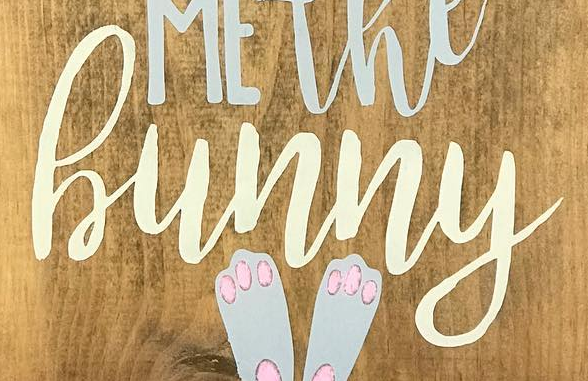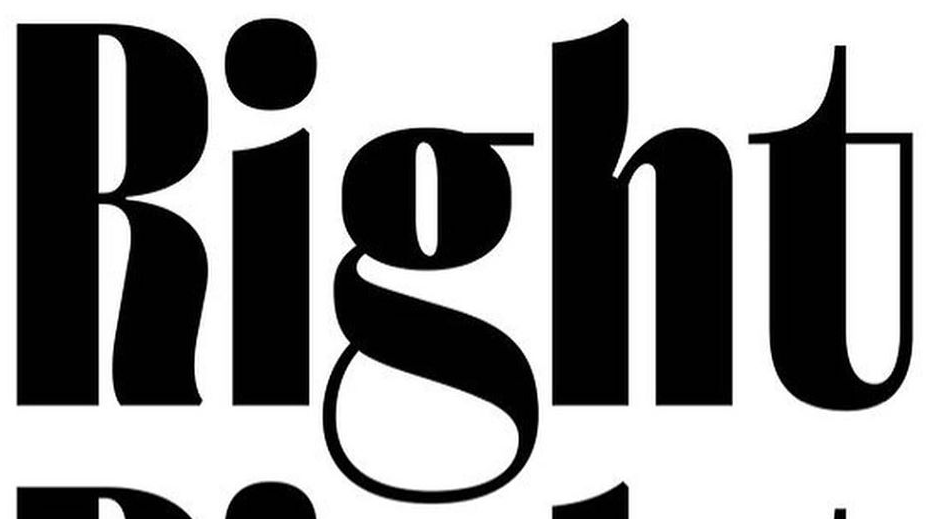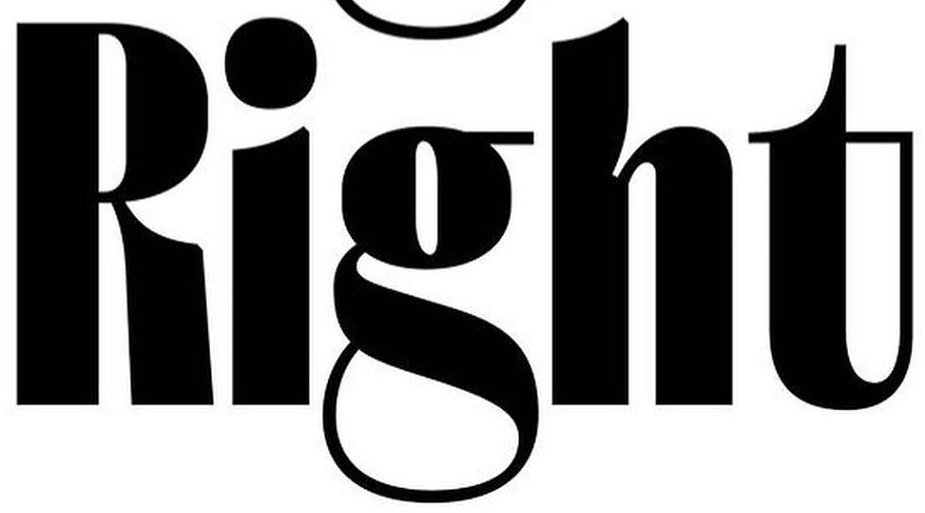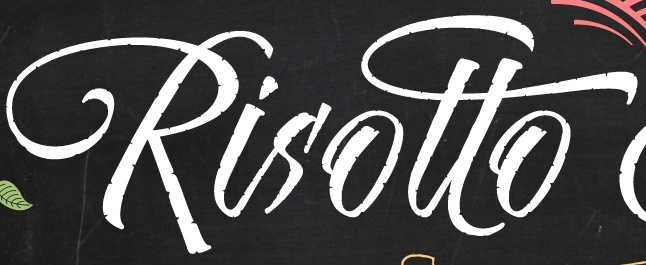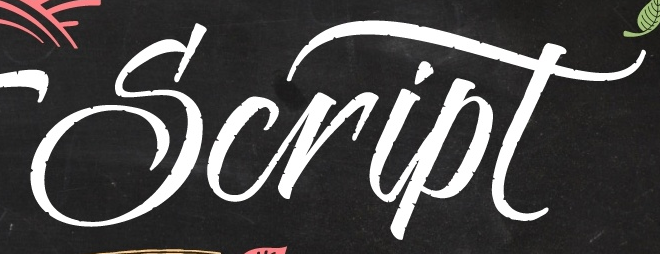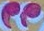Read the text content from these images in order, separated by a semicolon. hunny; Right; Right; Risotto; Script; " 